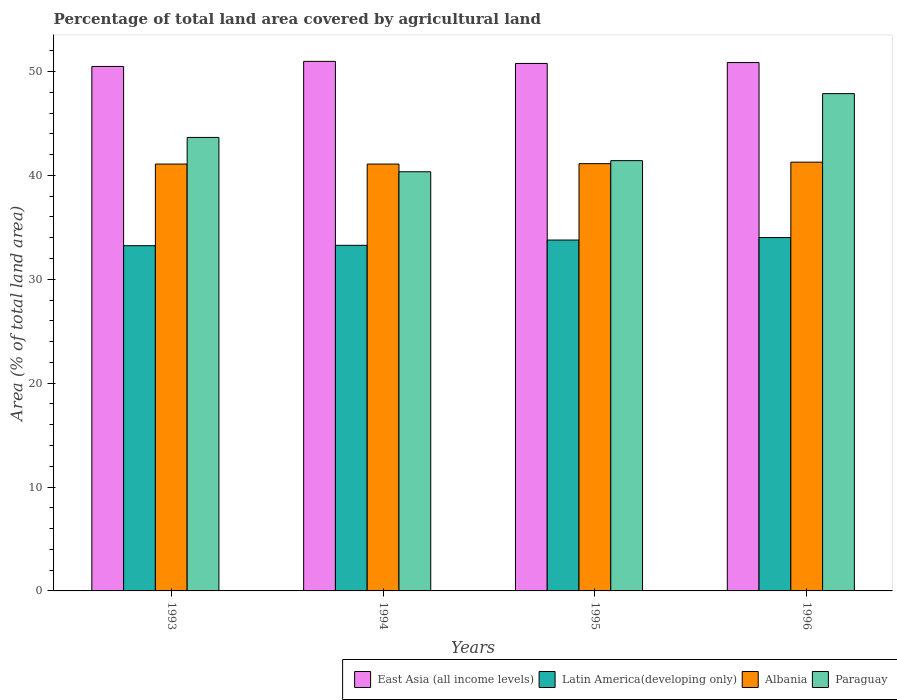How many bars are there on the 4th tick from the left?
Your answer should be compact. 4. How many bars are there on the 1st tick from the right?
Offer a terse response. 4. In how many cases, is the number of bars for a given year not equal to the number of legend labels?
Your answer should be very brief. 0. What is the percentage of agricultural land in Paraguay in 1996?
Keep it short and to the point. 47.88. Across all years, what is the maximum percentage of agricultural land in Latin America(developing only)?
Give a very brief answer. 34.02. Across all years, what is the minimum percentage of agricultural land in Paraguay?
Offer a very short reply. 40.35. In which year was the percentage of agricultural land in Latin America(developing only) minimum?
Give a very brief answer. 1993. What is the total percentage of agricultural land in East Asia (all income levels) in the graph?
Ensure brevity in your answer.  203.12. What is the difference between the percentage of agricultural land in Latin America(developing only) in 1993 and that in 1995?
Your response must be concise. -0.54. What is the difference between the percentage of agricultural land in East Asia (all income levels) in 1996 and the percentage of agricultural land in Latin America(developing only) in 1994?
Your answer should be very brief. 17.6. What is the average percentage of agricultural land in Albania per year?
Offer a terse response. 41.15. In the year 1996, what is the difference between the percentage of agricultural land in Paraguay and percentage of agricultural land in Latin America(developing only)?
Provide a succinct answer. 13.86. In how many years, is the percentage of agricultural land in Latin America(developing only) greater than 28 %?
Your response must be concise. 4. What is the ratio of the percentage of agricultural land in Latin America(developing only) in 1993 to that in 1994?
Provide a short and direct response. 1. What is the difference between the highest and the second highest percentage of agricultural land in Paraguay?
Make the answer very short. 4.22. What is the difference between the highest and the lowest percentage of agricultural land in East Asia (all income levels)?
Keep it short and to the point. 0.49. In how many years, is the percentage of agricultural land in Paraguay greater than the average percentage of agricultural land in Paraguay taken over all years?
Offer a very short reply. 2. Is the sum of the percentage of agricultural land in Latin America(developing only) in 1994 and 1996 greater than the maximum percentage of agricultural land in Paraguay across all years?
Provide a short and direct response. Yes. Is it the case that in every year, the sum of the percentage of agricultural land in Albania and percentage of agricultural land in Paraguay is greater than the sum of percentage of agricultural land in East Asia (all income levels) and percentage of agricultural land in Latin America(developing only)?
Provide a short and direct response. Yes. What does the 3rd bar from the left in 1993 represents?
Offer a terse response. Albania. What does the 1st bar from the right in 1993 represents?
Offer a terse response. Paraguay. Are the values on the major ticks of Y-axis written in scientific E-notation?
Provide a succinct answer. No. Does the graph contain any zero values?
Offer a very short reply. No. Does the graph contain grids?
Offer a terse response. No. Where does the legend appear in the graph?
Provide a succinct answer. Bottom right. How many legend labels are there?
Keep it short and to the point. 4. How are the legend labels stacked?
Provide a short and direct response. Horizontal. What is the title of the graph?
Offer a terse response. Percentage of total land area covered by agricultural land. Does "Europe(developing only)" appear as one of the legend labels in the graph?
Your answer should be very brief. No. What is the label or title of the Y-axis?
Your answer should be very brief. Area (% of total land area). What is the Area (% of total land area) in East Asia (all income levels) in 1993?
Provide a succinct answer. 50.49. What is the Area (% of total land area) in Latin America(developing only) in 1993?
Make the answer very short. 33.24. What is the Area (% of total land area) of Albania in 1993?
Offer a terse response. 41.09. What is the Area (% of total land area) of Paraguay in 1993?
Your response must be concise. 43.66. What is the Area (% of total land area) of East Asia (all income levels) in 1994?
Offer a very short reply. 50.98. What is the Area (% of total land area) of Latin America(developing only) in 1994?
Your response must be concise. 33.27. What is the Area (% of total land area) in Albania in 1994?
Ensure brevity in your answer.  41.09. What is the Area (% of total land area) of Paraguay in 1994?
Keep it short and to the point. 40.35. What is the Area (% of total land area) of East Asia (all income levels) in 1995?
Provide a succinct answer. 50.78. What is the Area (% of total land area) of Latin America(developing only) in 1995?
Offer a very short reply. 33.78. What is the Area (% of total land area) in Albania in 1995?
Offer a terse response. 41.13. What is the Area (% of total land area) of Paraguay in 1995?
Your response must be concise. 41.42. What is the Area (% of total land area) in East Asia (all income levels) in 1996?
Offer a terse response. 50.87. What is the Area (% of total land area) of Latin America(developing only) in 1996?
Make the answer very short. 34.02. What is the Area (% of total land area) of Albania in 1996?
Provide a succinct answer. 41.28. What is the Area (% of total land area) of Paraguay in 1996?
Provide a short and direct response. 47.88. Across all years, what is the maximum Area (% of total land area) in East Asia (all income levels)?
Your answer should be compact. 50.98. Across all years, what is the maximum Area (% of total land area) in Latin America(developing only)?
Offer a very short reply. 34.02. Across all years, what is the maximum Area (% of total land area) in Albania?
Your answer should be very brief. 41.28. Across all years, what is the maximum Area (% of total land area) of Paraguay?
Your answer should be very brief. 47.88. Across all years, what is the minimum Area (% of total land area) of East Asia (all income levels)?
Provide a short and direct response. 50.49. Across all years, what is the minimum Area (% of total land area) of Latin America(developing only)?
Offer a very short reply. 33.24. Across all years, what is the minimum Area (% of total land area) of Albania?
Provide a succinct answer. 41.09. Across all years, what is the minimum Area (% of total land area) of Paraguay?
Your response must be concise. 40.35. What is the total Area (% of total land area) of East Asia (all income levels) in the graph?
Your answer should be very brief. 203.12. What is the total Area (% of total land area) of Latin America(developing only) in the graph?
Offer a very short reply. 134.31. What is the total Area (% of total land area) in Albania in the graph?
Offer a very short reply. 164.6. What is the total Area (% of total land area) in Paraguay in the graph?
Your answer should be very brief. 173.31. What is the difference between the Area (% of total land area) of East Asia (all income levels) in 1993 and that in 1994?
Give a very brief answer. -0.49. What is the difference between the Area (% of total land area) in Latin America(developing only) in 1993 and that in 1994?
Keep it short and to the point. -0.04. What is the difference between the Area (% of total land area) of Paraguay in 1993 and that in 1994?
Keep it short and to the point. 3.3. What is the difference between the Area (% of total land area) of East Asia (all income levels) in 1993 and that in 1995?
Ensure brevity in your answer.  -0.29. What is the difference between the Area (% of total land area) in Latin America(developing only) in 1993 and that in 1995?
Your answer should be compact. -0.54. What is the difference between the Area (% of total land area) of Albania in 1993 and that in 1995?
Your answer should be very brief. -0.04. What is the difference between the Area (% of total land area) in Paraguay in 1993 and that in 1995?
Provide a short and direct response. 2.23. What is the difference between the Area (% of total land area) in East Asia (all income levels) in 1993 and that in 1996?
Offer a terse response. -0.37. What is the difference between the Area (% of total land area) in Latin America(developing only) in 1993 and that in 1996?
Your answer should be compact. -0.78. What is the difference between the Area (% of total land area) in Albania in 1993 and that in 1996?
Your answer should be very brief. -0.18. What is the difference between the Area (% of total land area) in Paraguay in 1993 and that in 1996?
Offer a terse response. -4.22. What is the difference between the Area (% of total land area) of East Asia (all income levels) in 1994 and that in 1995?
Make the answer very short. 0.2. What is the difference between the Area (% of total land area) of Latin America(developing only) in 1994 and that in 1995?
Provide a short and direct response. -0.51. What is the difference between the Area (% of total land area) in Albania in 1994 and that in 1995?
Offer a very short reply. -0.04. What is the difference between the Area (% of total land area) in Paraguay in 1994 and that in 1995?
Give a very brief answer. -1.07. What is the difference between the Area (% of total land area) in East Asia (all income levels) in 1994 and that in 1996?
Ensure brevity in your answer.  0.12. What is the difference between the Area (% of total land area) of Latin America(developing only) in 1994 and that in 1996?
Give a very brief answer. -0.75. What is the difference between the Area (% of total land area) in Albania in 1994 and that in 1996?
Give a very brief answer. -0.18. What is the difference between the Area (% of total land area) of Paraguay in 1994 and that in 1996?
Provide a short and direct response. -7.52. What is the difference between the Area (% of total land area) of East Asia (all income levels) in 1995 and that in 1996?
Your answer should be compact. -0.09. What is the difference between the Area (% of total land area) of Latin America(developing only) in 1995 and that in 1996?
Keep it short and to the point. -0.24. What is the difference between the Area (% of total land area) of Albania in 1995 and that in 1996?
Make the answer very short. -0.15. What is the difference between the Area (% of total land area) of Paraguay in 1995 and that in 1996?
Give a very brief answer. -6.45. What is the difference between the Area (% of total land area) of East Asia (all income levels) in 1993 and the Area (% of total land area) of Latin America(developing only) in 1994?
Keep it short and to the point. 17.22. What is the difference between the Area (% of total land area) of East Asia (all income levels) in 1993 and the Area (% of total land area) of Albania in 1994?
Your answer should be very brief. 9.4. What is the difference between the Area (% of total land area) of East Asia (all income levels) in 1993 and the Area (% of total land area) of Paraguay in 1994?
Give a very brief answer. 10.14. What is the difference between the Area (% of total land area) in Latin America(developing only) in 1993 and the Area (% of total land area) in Albania in 1994?
Keep it short and to the point. -7.86. What is the difference between the Area (% of total land area) of Latin America(developing only) in 1993 and the Area (% of total land area) of Paraguay in 1994?
Your answer should be very brief. -7.12. What is the difference between the Area (% of total land area) of Albania in 1993 and the Area (% of total land area) of Paraguay in 1994?
Your answer should be compact. 0.74. What is the difference between the Area (% of total land area) of East Asia (all income levels) in 1993 and the Area (% of total land area) of Latin America(developing only) in 1995?
Offer a very short reply. 16.71. What is the difference between the Area (% of total land area) in East Asia (all income levels) in 1993 and the Area (% of total land area) in Albania in 1995?
Keep it short and to the point. 9.36. What is the difference between the Area (% of total land area) in East Asia (all income levels) in 1993 and the Area (% of total land area) in Paraguay in 1995?
Give a very brief answer. 9.07. What is the difference between the Area (% of total land area) of Latin America(developing only) in 1993 and the Area (% of total land area) of Albania in 1995?
Make the answer very short. -7.9. What is the difference between the Area (% of total land area) of Latin America(developing only) in 1993 and the Area (% of total land area) of Paraguay in 1995?
Give a very brief answer. -8.19. What is the difference between the Area (% of total land area) of Albania in 1993 and the Area (% of total land area) of Paraguay in 1995?
Your response must be concise. -0.33. What is the difference between the Area (% of total land area) of East Asia (all income levels) in 1993 and the Area (% of total land area) of Latin America(developing only) in 1996?
Provide a short and direct response. 16.47. What is the difference between the Area (% of total land area) in East Asia (all income levels) in 1993 and the Area (% of total land area) in Albania in 1996?
Ensure brevity in your answer.  9.21. What is the difference between the Area (% of total land area) in East Asia (all income levels) in 1993 and the Area (% of total land area) in Paraguay in 1996?
Keep it short and to the point. 2.62. What is the difference between the Area (% of total land area) in Latin America(developing only) in 1993 and the Area (% of total land area) in Albania in 1996?
Give a very brief answer. -8.04. What is the difference between the Area (% of total land area) in Latin America(developing only) in 1993 and the Area (% of total land area) in Paraguay in 1996?
Your response must be concise. -14.64. What is the difference between the Area (% of total land area) in Albania in 1993 and the Area (% of total land area) in Paraguay in 1996?
Make the answer very short. -6.78. What is the difference between the Area (% of total land area) in East Asia (all income levels) in 1994 and the Area (% of total land area) in Latin America(developing only) in 1995?
Your answer should be compact. 17.2. What is the difference between the Area (% of total land area) in East Asia (all income levels) in 1994 and the Area (% of total land area) in Albania in 1995?
Give a very brief answer. 9.85. What is the difference between the Area (% of total land area) in East Asia (all income levels) in 1994 and the Area (% of total land area) in Paraguay in 1995?
Your answer should be very brief. 9.56. What is the difference between the Area (% of total land area) in Latin America(developing only) in 1994 and the Area (% of total land area) in Albania in 1995?
Provide a short and direct response. -7.86. What is the difference between the Area (% of total land area) of Latin America(developing only) in 1994 and the Area (% of total land area) of Paraguay in 1995?
Make the answer very short. -8.15. What is the difference between the Area (% of total land area) in Albania in 1994 and the Area (% of total land area) in Paraguay in 1995?
Offer a very short reply. -0.33. What is the difference between the Area (% of total land area) in East Asia (all income levels) in 1994 and the Area (% of total land area) in Latin America(developing only) in 1996?
Ensure brevity in your answer.  16.96. What is the difference between the Area (% of total land area) in East Asia (all income levels) in 1994 and the Area (% of total land area) in Albania in 1996?
Ensure brevity in your answer.  9.7. What is the difference between the Area (% of total land area) in East Asia (all income levels) in 1994 and the Area (% of total land area) in Paraguay in 1996?
Keep it short and to the point. 3.11. What is the difference between the Area (% of total land area) of Latin America(developing only) in 1994 and the Area (% of total land area) of Albania in 1996?
Give a very brief answer. -8.01. What is the difference between the Area (% of total land area) in Latin America(developing only) in 1994 and the Area (% of total land area) in Paraguay in 1996?
Provide a succinct answer. -14.6. What is the difference between the Area (% of total land area) of Albania in 1994 and the Area (% of total land area) of Paraguay in 1996?
Provide a succinct answer. -6.78. What is the difference between the Area (% of total land area) of East Asia (all income levels) in 1995 and the Area (% of total land area) of Latin America(developing only) in 1996?
Offer a very short reply. 16.76. What is the difference between the Area (% of total land area) of East Asia (all income levels) in 1995 and the Area (% of total land area) of Albania in 1996?
Give a very brief answer. 9.5. What is the difference between the Area (% of total land area) in East Asia (all income levels) in 1995 and the Area (% of total land area) in Paraguay in 1996?
Your answer should be very brief. 2.9. What is the difference between the Area (% of total land area) in Latin America(developing only) in 1995 and the Area (% of total land area) in Albania in 1996?
Provide a short and direct response. -7.5. What is the difference between the Area (% of total land area) of Latin America(developing only) in 1995 and the Area (% of total land area) of Paraguay in 1996?
Offer a very short reply. -14.1. What is the difference between the Area (% of total land area) in Albania in 1995 and the Area (% of total land area) in Paraguay in 1996?
Make the answer very short. -6.74. What is the average Area (% of total land area) in East Asia (all income levels) per year?
Your response must be concise. 50.78. What is the average Area (% of total land area) in Latin America(developing only) per year?
Provide a succinct answer. 33.58. What is the average Area (% of total land area) in Albania per year?
Ensure brevity in your answer.  41.15. What is the average Area (% of total land area) in Paraguay per year?
Make the answer very short. 43.33. In the year 1993, what is the difference between the Area (% of total land area) of East Asia (all income levels) and Area (% of total land area) of Latin America(developing only)?
Offer a terse response. 17.26. In the year 1993, what is the difference between the Area (% of total land area) in East Asia (all income levels) and Area (% of total land area) in Albania?
Your answer should be very brief. 9.4. In the year 1993, what is the difference between the Area (% of total land area) in East Asia (all income levels) and Area (% of total land area) in Paraguay?
Ensure brevity in your answer.  6.83. In the year 1993, what is the difference between the Area (% of total land area) of Latin America(developing only) and Area (% of total land area) of Albania?
Provide a short and direct response. -7.86. In the year 1993, what is the difference between the Area (% of total land area) in Latin America(developing only) and Area (% of total land area) in Paraguay?
Offer a terse response. -10.42. In the year 1993, what is the difference between the Area (% of total land area) of Albania and Area (% of total land area) of Paraguay?
Provide a short and direct response. -2.56. In the year 1994, what is the difference between the Area (% of total land area) in East Asia (all income levels) and Area (% of total land area) in Latin America(developing only)?
Make the answer very short. 17.71. In the year 1994, what is the difference between the Area (% of total land area) of East Asia (all income levels) and Area (% of total land area) of Albania?
Give a very brief answer. 9.89. In the year 1994, what is the difference between the Area (% of total land area) of East Asia (all income levels) and Area (% of total land area) of Paraguay?
Give a very brief answer. 10.63. In the year 1994, what is the difference between the Area (% of total land area) in Latin America(developing only) and Area (% of total land area) in Albania?
Make the answer very short. -7.82. In the year 1994, what is the difference between the Area (% of total land area) in Latin America(developing only) and Area (% of total land area) in Paraguay?
Give a very brief answer. -7.08. In the year 1994, what is the difference between the Area (% of total land area) in Albania and Area (% of total land area) in Paraguay?
Provide a succinct answer. 0.74. In the year 1995, what is the difference between the Area (% of total land area) in East Asia (all income levels) and Area (% of total land area) in Latin America(developing only)?
Your answer should be very brief. 17. In the year 1995, what is the difference between the Area (% of total land area) of East Asia (all income levels) and Area (% of total land area) of Albania?
Your response must be concise. 9.65. In the year 1995, what is the difference between the Area (% of total land area) of East Asia (all income levels) and Area (% of total land area) of Paraguay?
Make the answer very short. 9.36. In the year 1995, what is the difference between the Area (% of total land area) of Latin America(developing only) and Area (% of total land area) of Albania?
Make the answer very short. -7.35. In the year 1995, what is the difference between the Area (% of total land area) in Latin America(developing only) and Area (% of total land area) in Paraguay?
Provide a succinct answer. -7.65. In the year 1995, what is the difference between the Area (% of total land area) in Albania and Area (% of total land area) in Paraguay?
Provide a short and direct response. -0.29. In the year 1996, what is the difference between the Area (% of total land area) in East Asia (all income levels) and Area (% of total land area) in Latin America(developing only)?
Your answer should be very brief. 16.85. In the year 1996, what is the difference between the Area (% of total land area) in East Asia (all income levels) and Area (% of total land area) in Albania?
Your response must be concise. 9.59. In the year 1996, what is the difference between the Area (% of total land area) of East Asia (all income levels) and Area (% of total land area) of Paraguay?
Offer a very short reply. 2.99. In the year 1996, what is the difference between the Area (% of total land area) in Latin America(developing only) and Area (% of total land area) in Albania?
Offer a very short reply. -7.26. In the year 1996, what is the difference between the Area (% of total land area) in Latin America(developing only) and Area (% of total land area) in Paraguay?
Provide a short and direct response. -13.86. In the year 1996, what is the difference between the Area (% of total land area) of Albania and Area (% of total land area) of Paraguay?
Your response must be concise. -6.6. What is the ratio of the Area (% of total land area) in Latin America(developing only) in 1993 to that in 1994?
Give a very brief answer. 1. What is the ratio of the Area (% of total land area) in Albania in 1993 to that in 1994?
Your answer should be compact. 1. What is the ratio of the Area (% of total land area) of Paraguay in 1993 to that in 1994?
Offer a terse response. 1.08. What is the ratio of the Area (% of total land area) in East Asia (all income levels) in 1993 to that in 1995?
Provide a short and direct response. 0.99. What is the ratio of the Area (% of total land area) of Latin America(developing only) in 1993 to that in 1995?
Your response must be concise. 0.98. What is the ratio of the Area (% of total land area) in Albania in 1993 to that in 1995?
Keep it short and to the point. 1. What is the ratio of the Area (% of total land area) of Paraguay in 1993 to that in 1995?
Keep it short and to the point. 1.05. What is the ratio of the Area (% of total land area) of East Asia (all income levels) in 1993 to that in 1996?
Your response must be concise. 0.99. What is the ratio of the Area (% of total land area) in Latin America(developing only) in 1993 to that in 1996?
Your answer should be very brief. 0.98. What is the ratio of the Area (% of total land area) of Albania in 1993 to that in 1996?
Offer a terse response. 1. What is the ratio of the Area (% of total land area) in Paraguay in 1993 to that in 1996?
Offer a terse response. 0.91. What is the ratio of the Area (% of total land area) in Paraguay in 1994 to that in 1995?
Provide a short and direct response. 0.97. What is the ratio of the Area (% of total land area) in Latin America(developing only) in 1994 to that in 1996?
Keep it short and to the point. 0.98. What is the ratio of the Area (% of total land area) in Albania in 1994 to that in 1996?
Your response must be concise. 1. What is the ratio of the Area (% of total land area) in Paraguay in 1994 to that in 1996?
Ensure brevity in your answer.  0.84. What is the ratio of the Area (% of total land area) of East Asia (all income levels) in 1995 to that in 1996?
Keep it short and to the point. 1. What is the ratio of the Area (% of total land area) of Latin America(developing only) in 1995 to that in 1996?
Offer a very short reply. 0.99. What is the ratio of the Area (% of total land area) of Albania in 1995 to that in 1996?
Offer a terse response. 1. What is the ratio of the Area (% of total land area) of Paraguay in 1995 to that in 1996?
Your answer should be compact. 0.87. What is the difference between the highest and the second highest Area (% of total land area) in East Asia (all income levels)?
Keep it short and to the point. 0.12. What is the difference between the highest and the second highest Area (% of total land area) in Latin America(developing only)?
Provide a short and direct response. 0.24. What is the difference between the highest and the second highest Area (% of total land area) in Albania?
Your answer should be very brief. 0.15. What is the difference between the highest and the second highest Area (% of total land area) of Paraguay?
Make the answer very short. 4.22. What is the difference between the highest and the lowest Area (% of total land area) of East Asia (all income levels)?
Offer a terse response. 0.49. What is the difference between the highest and the lowest Area (% of total land area) in Latin America(developing only)?
Your response must be concise. 0.78. What is the difference between the highest and the lowest Area (% of total land area) in Albania?
Ensure brevity in your answer.  0.18. What is the difference between the highest and the lowest Area (% of total land area) in Paraguay?
Offer a terse response. 7.52. 